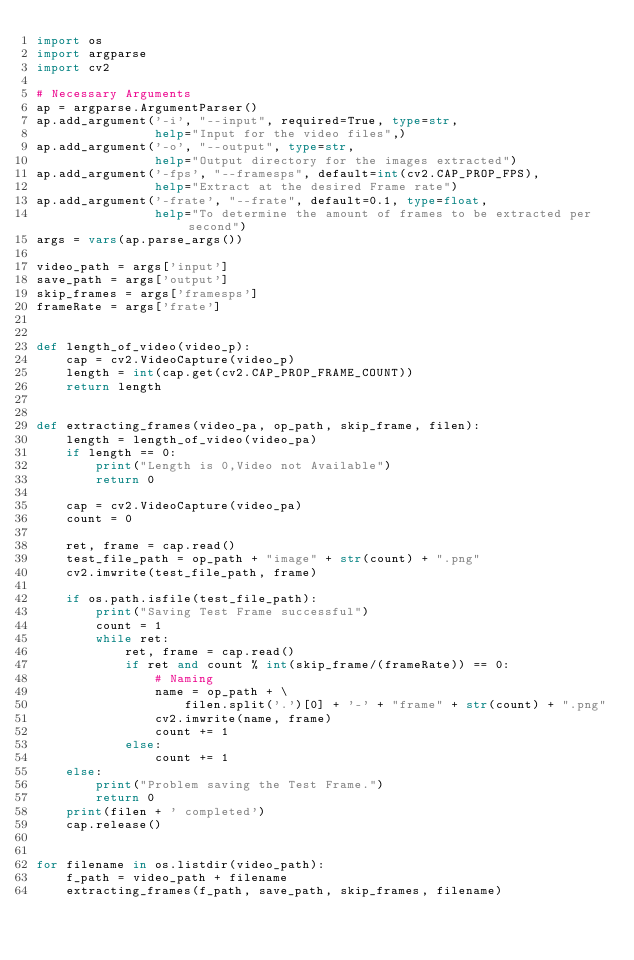<code> <loc_0><loc_0><loc_500><loc_500><_Python_>import os
import argparse
import cv2

# Necessary Arguments
ap = argparse.ArgumentParser()
ap.add_argument('-i', "--input", required=True, type=str,
                help="Input for the video files",)
ap.add_argument('-o', "--output", type=str,
                help="Output directory for the images extracted")
ap.add_argument('-fps', "--framesps", default=int(cv2.CAP_PROP_FPS),
                help="Extract at the desired Frame rate")
ap.add_argument('-frate', "--frate", default=0.1, type=float,
                help="To determine the amount of frames to be extracted per second")
args = vars(ap.parse_args())

video_path = args['input']
save_path = args['output']
skip_frames = args['framesps']
frameRate = args['frate']


def length_of_video(video_p):
    cap = cv2.VideoCapture(video_p)
    length = int(cap.get(cv2.CAP_PROP_FRAME_COUNT))
    return length


def extracting_frames(video_pa, op_path, skip_frame, filen):
    length = length_of_video(video_pa)
    if length == 0:
        print("Length is 0,Video not Available")
        return 0

    cap = cv2.VideoCapture(video_pa)
    count = 0

    ret, frame = cap.read()
    test_file_path = op_path + "image" + str(count) + ".png"
    cv2.imwrite(test_file_path, frame)

    if os.path.isfile(test_file_path):
        print("Saving Test Frame successful")
        count = 1
        while ret:
            ret, frame = cap.read()
            if ret and count % int(skip_frame/(frameRate)) == 0:
                # Naming
                name = op_path + \
                    filen.split('.')[0] + '-' + "frame" + str(count) + ".png"
                cv2.imwrite(name, frame)
                count += 1
            else:
                count += 1
    else:
        print("Problem saving the Test Frame.")
        return 0
    print(filen + ' completed')
    cap.release()


for filename in os.listdir(video_path):
    f_path = video_path + filename
    extracting_frames(f_path, save_path, skip_frames, filename)
</code> 